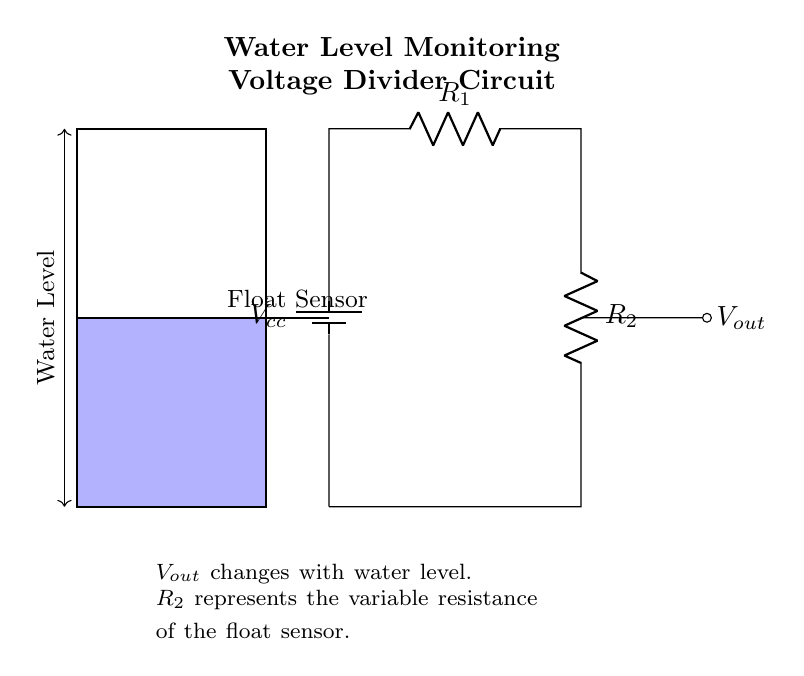What does R1 represent in the circuit? R1 represents a resistor in the voltage divider network. It is one of the two resistors that create the division of voltage based on the resistance values.
Answer: Resistor What is the purpose of the float sensor? The float sensor is used to monitor the water level in the reservoir. As the water level changes, the resistance of the float sensor (R2) varies, affecting the output voltage (Vout).
Answer: Monitoring What is Vout? Vout is the output voltage taken from the junction of R1 and R2 in the voltage divider. It varies depending on the water level in the reservoir as influenced by the float sensor.
Answer: Output voltage How does Vout change with water level? Vout decreases when the water level rises because the resistance R2 decreases. According to the voltage divider rule, a lower resistance (R2) results in a lower output voltage (Vout).
Answer: Decreases What happens to R2 when the water level drops? When the water level drops, R2 increases in resistance because the float sensor will allow for more resistance as it is less submerged. This change affects Vout.
Answer: Increases What is the configuration of this circuit? The configuration is a series circuit involving two resistors (R1 and R2) which creates a voltage divider specifically for the purpose of monitoring.
Answer: Series 